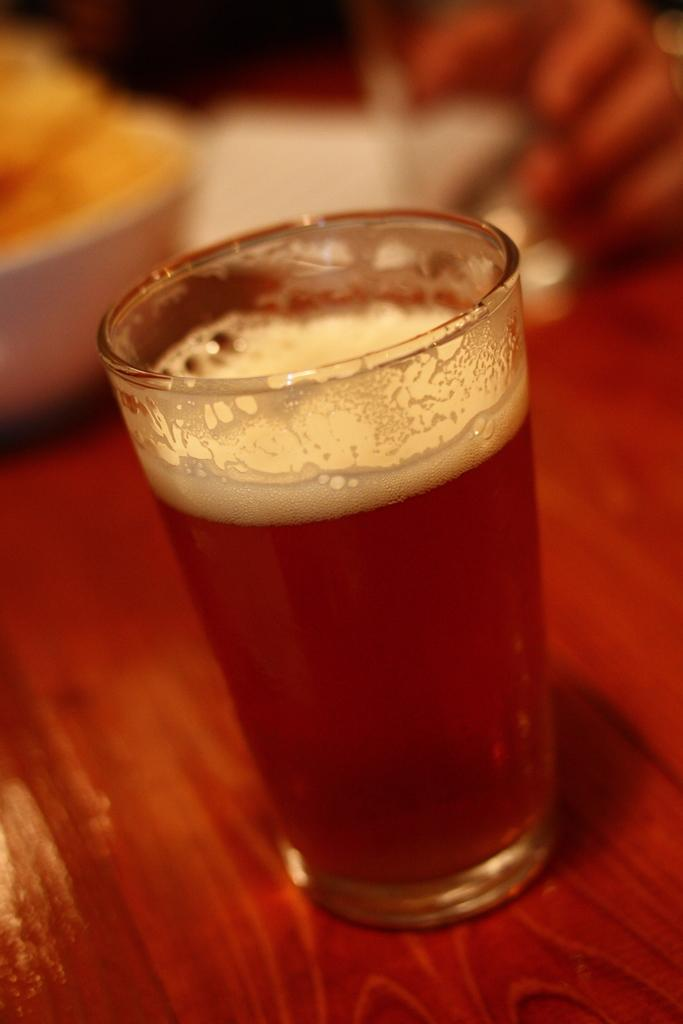What object is present on a wooden surface in the image? There is a glass on a wooden surface in the image. What is inside the glass? There is a liquid in the glass. Can you describe the background of the image? The background of the image is blurred. What type of adjustment can be seen being made to the field in the image? There is no field or adjustment present in the image; it only features a glass on a wooden surface with a blurred background. 